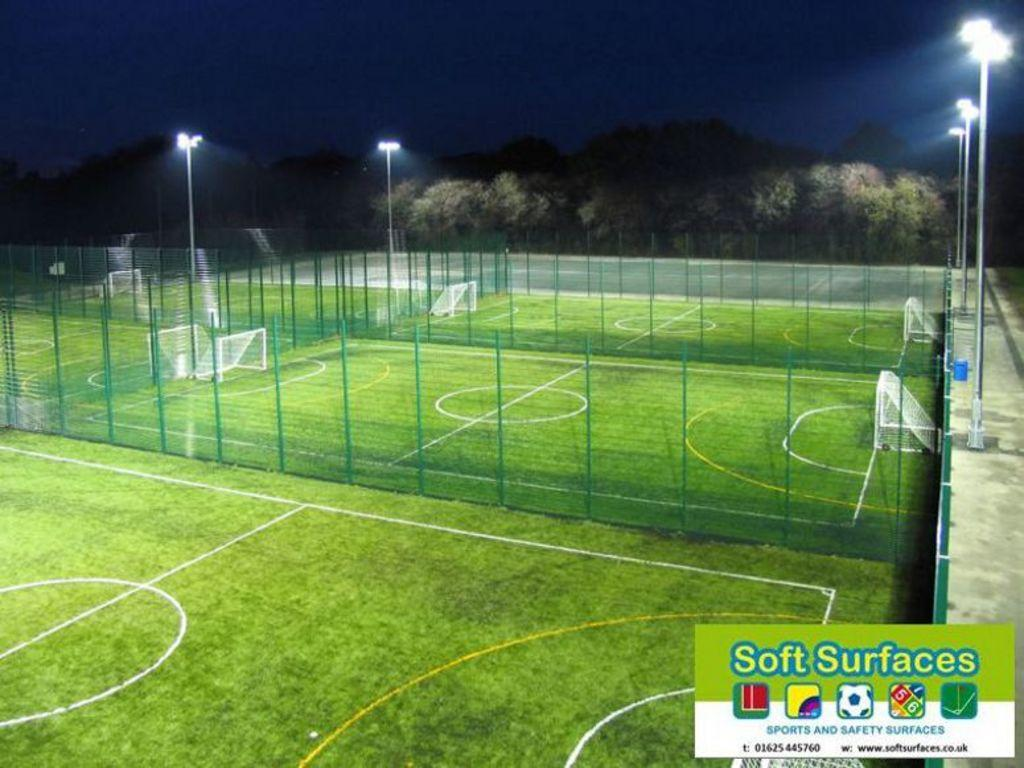<image>
Present a compact description of the photo's key features. A soft surfaces sport advertisement with fenced in soccer fields. 